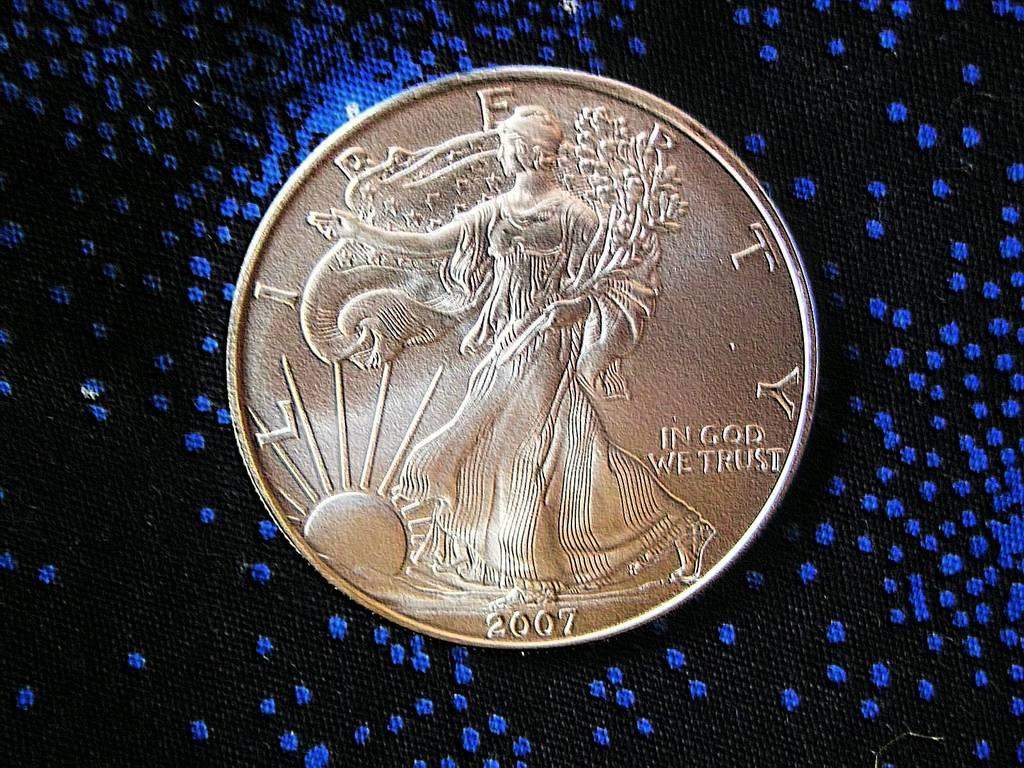<image>
Relay a brief, clear account of the picture shown. 2007 liberty dollar on a black and blue background 